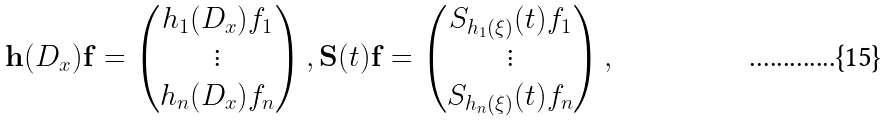<formula> <loc_0><loc_0><loc_500><loc_500>\mathbf h ( D _ { x } ) \mathbf f = \begin{pmatrix} h _ { 1 } ( D _ { x } ) f _ { 1 } \\ \vdots \\ h _ { n } ( D _ { x } ) f _ { n } \end{pmatrix} , \mathbf S ( t ) \mathbf f = \begin{pmatrix} S _ { h _ { 1 } ( \xi ) } ( t ) f _ { 1 } \\ \vdots \\ S _ { h _ { n } ( \xi ) } ( t ) f _ { n } \end{pmatrix} ,</formula> 